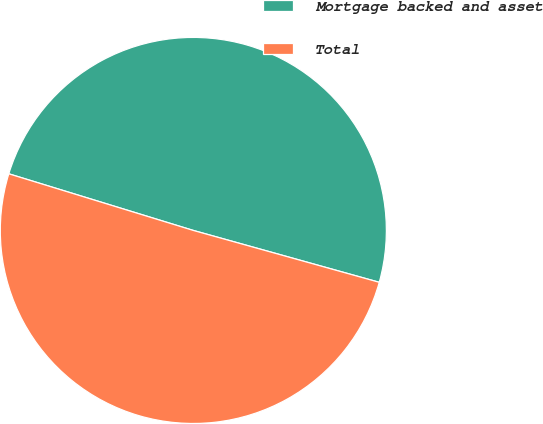<chart> <loc_0><loc_0><loc_500><loc_500><pie_chart><fcel>Mortgage backed and asset<fcel>Total<nl><fcel>49.59%<fcel>50.41%<nl></chart> 